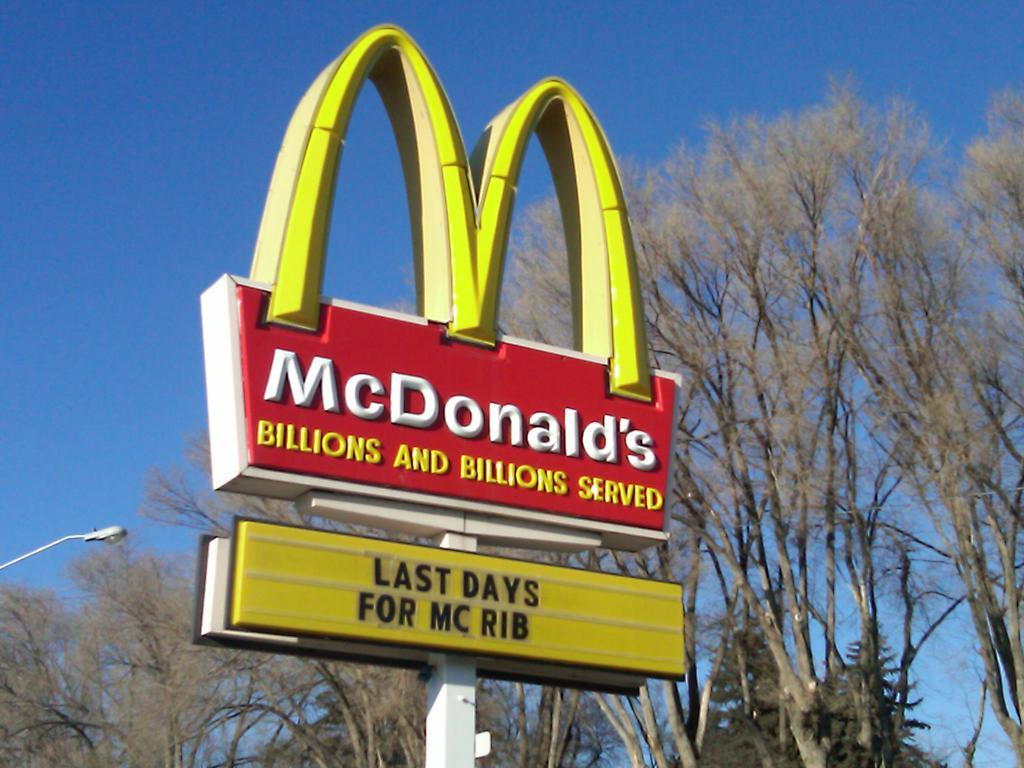What is the main subject in the foreground of the image? There is a McDonald's board in the foreground of the image. What can be seen in the middle of the image? There are trees and a street light in the middle of the image. What is visible in the background of the image? The sky is visible in the background of the image. What type of finger can be seen holding the McDonald's board in the image? There are no fingers visible in the image, as the McDonald's board is a sign and not being held by anyone. 